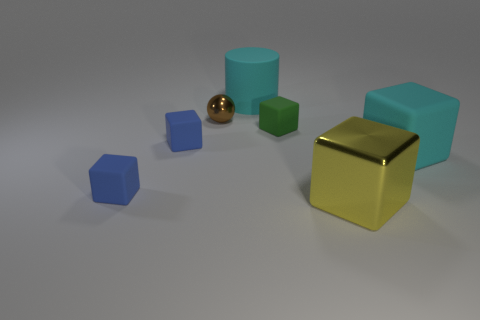Do the cylinder and the big matte cube have the same color?
Your response must be concise. Yes. Are there any matte cubes that have the same size as the metal ball?
Offer a terse response. Yes. How many things are either tiny matte blocks left of the big cyan cylinder or big rubber objects right of the big cylinder?
Make the answer very short. 3. The large cube that is to the right of the metal thing that is on the right side of the sphere is what color?
Offer a very short reply. Cyan. There is a large cylinder that is made of the same material as the tiny green cube; what color is it?
Your response must be concise. Cyan. How many large cubes are the same color as the big cylinder?
Offer a terse response. 1. How many things are tiny red cylinders or brown things?
Your response must be concise. 1. What shape is the brown metal thing that is the same size as the green block?
Your answer should be very brief. Sphere. What number of things are in front of the cyan rubber block and on the right side of the shiny ball?
Keep it short and to the point. 1. There is a small object behind the small green cube; what is its material?
Your response must be concise. Metal. 